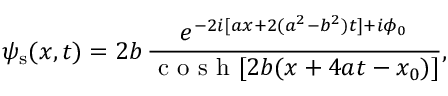<formula> <loc_0><loc_0><loc_500><loc_500>\psi _ { s } ( x , t ) = 2 b \, \frac { e ^ { - 2 i [ a x + 2 ( a ^ { 2 } - b ^ { 2 } ) t ] + i \phi _ { 0 } } } { c o s h [ 2 b ( x + 4 a t - x _ { 0 } ) ] } ,</formula> 